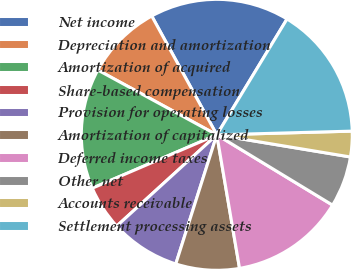Convert chart to OTSL. <chart><loc_0><loc_0><loc_500><loc_500><pie_chart><fcel>Net income<fcel>Depreciation and amortization<fcel>Amortization of acquired<fcel>Share-based compensation<fcel>Provision for operating losses<fcel>Amortization of capitalized<fcel>Deferred income taxes<fcel>Other net<fcel>Accounts receivable<fcel>Settlement processing assets<nl><fcel>16.65%<fcel>9.09%<fcel>14.38%<fcel>5.32%<fcel>8.34%<fcel>7.58%<fcel>13.63%<fcel>6.07%<fcel>3.05%<fcel>15.89%<nl></chart> 